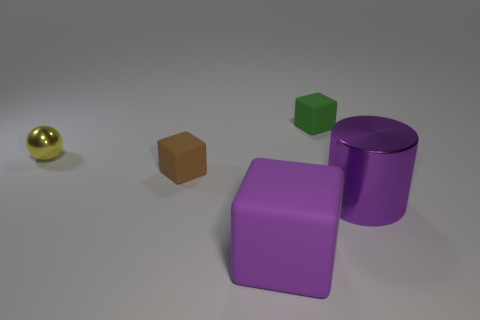What could be the purpose of arranging these objects like this, and what do you think it conveys? The arrangement of these objects might be for a visual study of geometric forms, colors, and textures. It emphasizes contrast and comparison, such as matte versus shiny surfaces, and the juxtaposition of different shapes in a neutral environment. It conveys a sense of harmony and order while also providing a straightforward representation of spatial concepts. 